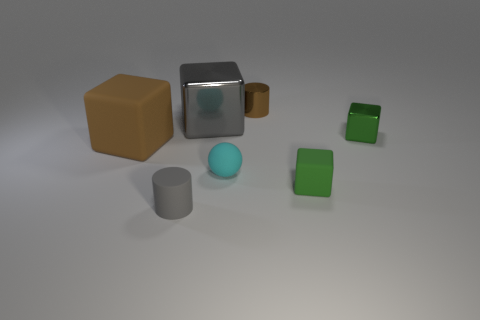What is the size of the cylinder that is the same color as the large metallic object?
Offer a very short reply. Small. Do the small cylinder in front of the large rubber thing and the big brown block have the same material?
Give a very brief answer. Yes. What is the color of the tiny rubber thing that is the same shape as the big brown object?
Your answer should be very brief. Green. What is the shape of the big shiny object?
Your answer should be compact. Cube. What number of things are large red metal things or tiny objects?
Make the answer very short. 5. Do the rubber thing behind the tiny cyan object and the cylinder that is in front of the small metallic cylinder have the same color?
Provide a short and direct response. No. What number of other objects are the same shape as the brown metallic object?
Offer a very short reply. 1. Are any cubes visible?
Provide a succinct answer. Yes. What number of objects are either big green cubes or objects on the right side of the matte sphere?
Provide a short and direct response. 3. Does the thing that is right of the green matte cube have the same size as the tiny gray cylinder?
Make the answer very short. Yes. 